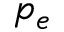<formula> <loc_0><loc_0><loc_500><loc_500>p _ { e }</formula> 